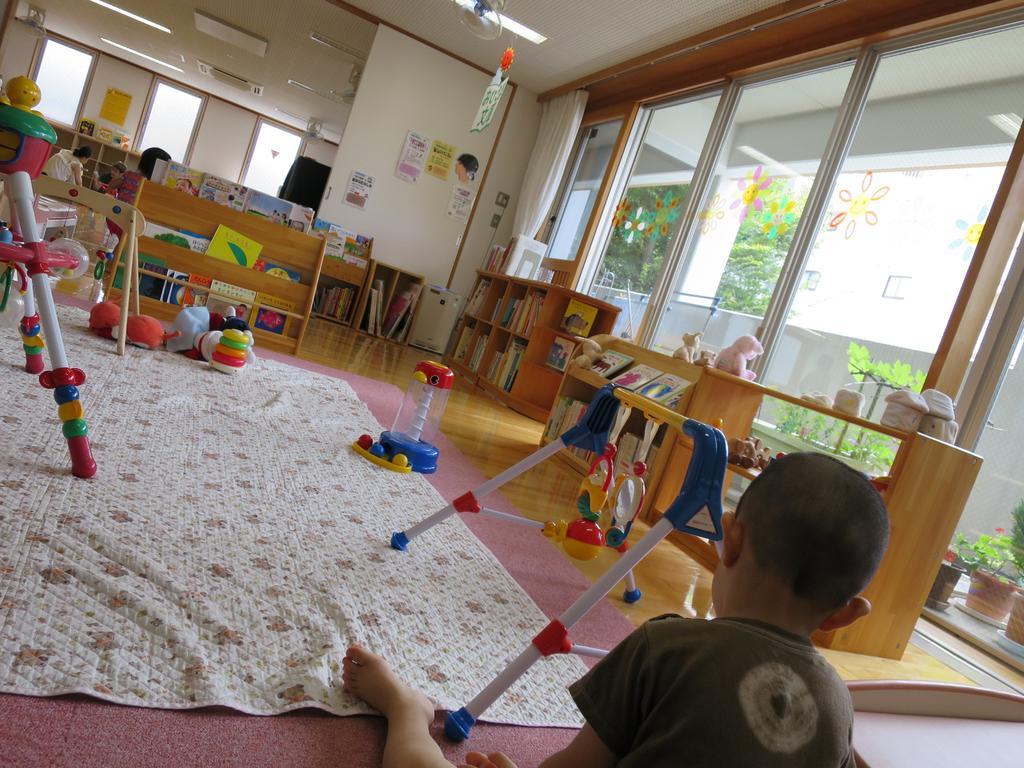Can you describe this image briefly? At the bottom of the image a boy is sitting on the floor. In front of him there are some toys, cloth and tables, on the tables there are some books and toys. Behind the tables there is wall, on the wall there are some glass windows, curtains and posters. Behind the tables two persons are sitting. At the top of the image there is ceiling and lights. Through the glass windows we can see some plants, trees and wall. 